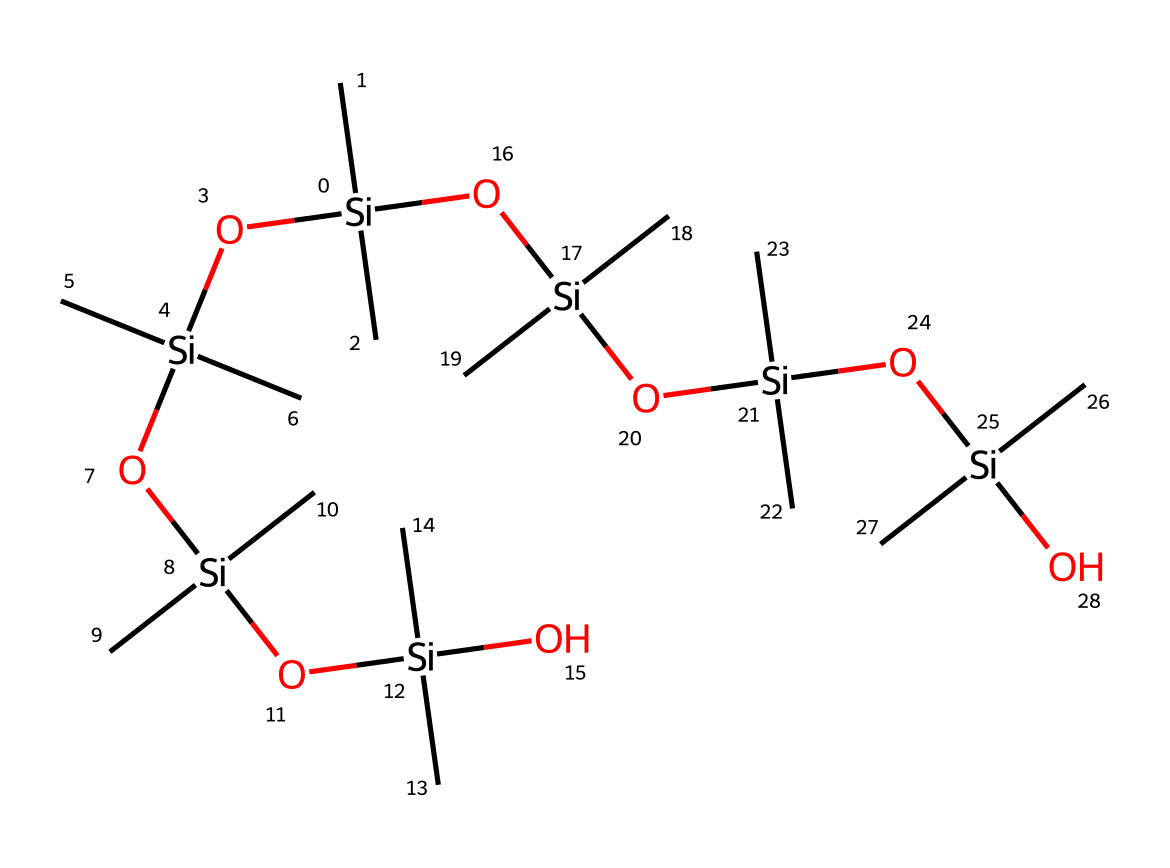What is the core atom in this structure? The chemical structure primarily consists of silicon atoms that form the backbone of the organosilicon compounds. The presence of [Si] indicates that silicon is a key component.
Answer: silicon How many silicon atoms are present in this structure? By analyzing the SMILES representation, it shows that there are six silicon atoms in total, as indicated by the number of occurrences of [Si] in the structure.
Answer: 6 What functional groups are present in this organosilicon compound? The structure contains hydroxyl groups (indicated by O) connected to the silicon atoms, which are typical in organosilicon compounds. These contribute to the flexibility and reactivity of the material.
Answer: hydroxyl What role do the silicon-oxygen bonds play in flexible biosensors? The silicon-oxygen bonds provide flexibility and stability, which are crucial for conforming to the skin and maintaining performance in wearable applications due to their ability to withstand bending and stretching.
Answer: flexibility How many total oxygen atoms are present in the SMILES structure? By counting the number of oxygen atoms represented by O in the SMILES, there are five oxygen atoms attached to the silicon framework.
Answer: 5 What is the implication of the branched structure for material properties? The branched structure enhances the viscoelastic properties of the material, allowing for better mechanical performance under varying conditions, which is beneficial in wearable applications.
Answer: viscoelasticity What type of interactions are likely prominent in this compound due to its chemical structure? The presence of both silicons and oxygens allows for hydrogen bonding and dipole-dipole interactions, which can enhance biocompatibility and adhesion properties for biosensor applications.
Answer: hydrogen bonding 